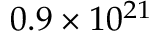Convert formula to latex. <formula><loc_0><loc_0><loc_500><loc_500>0 . 9 \times 1 0 ^ { 2 1 }</formula> 